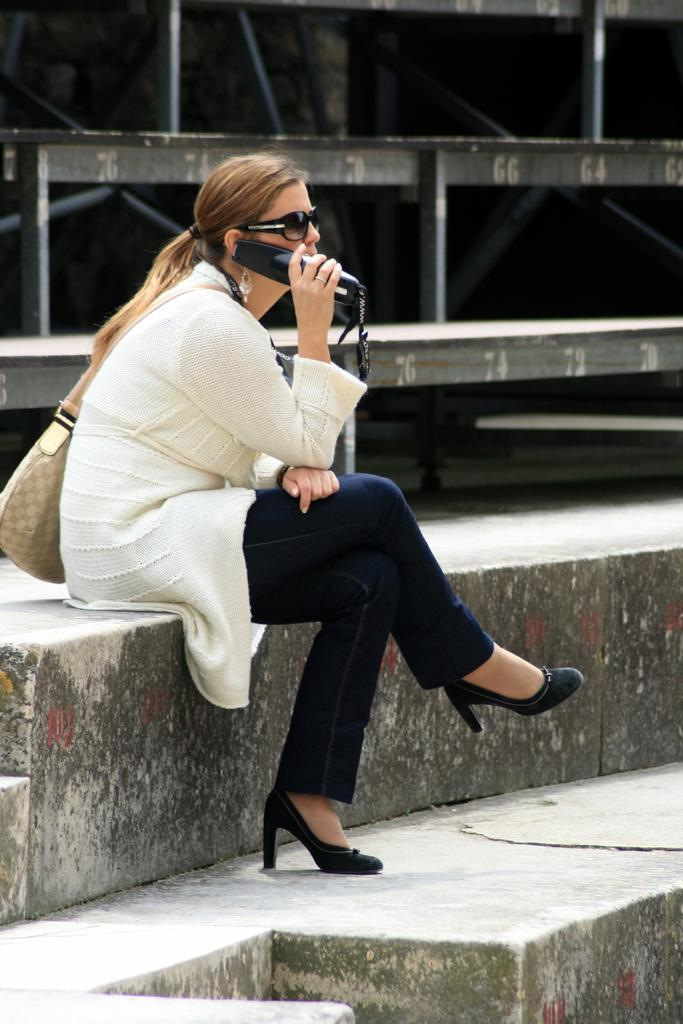What is the woman in the image doing? The woman is sitting in the image and holding a device. What can be seen at the back of the image? There are rods at the back of the image, with numbers on them. What architectural feature is present at the bottom of the image? There is a staircase at the bottom of the image. What is the woman's sister doing in the image? There is no mention of a sister in the image, so we cannot answer this question. What is the sum of the numbers on the rods in the image? We cannot answer this question as we do not have the specific numbers on the rods to perform the addition. 